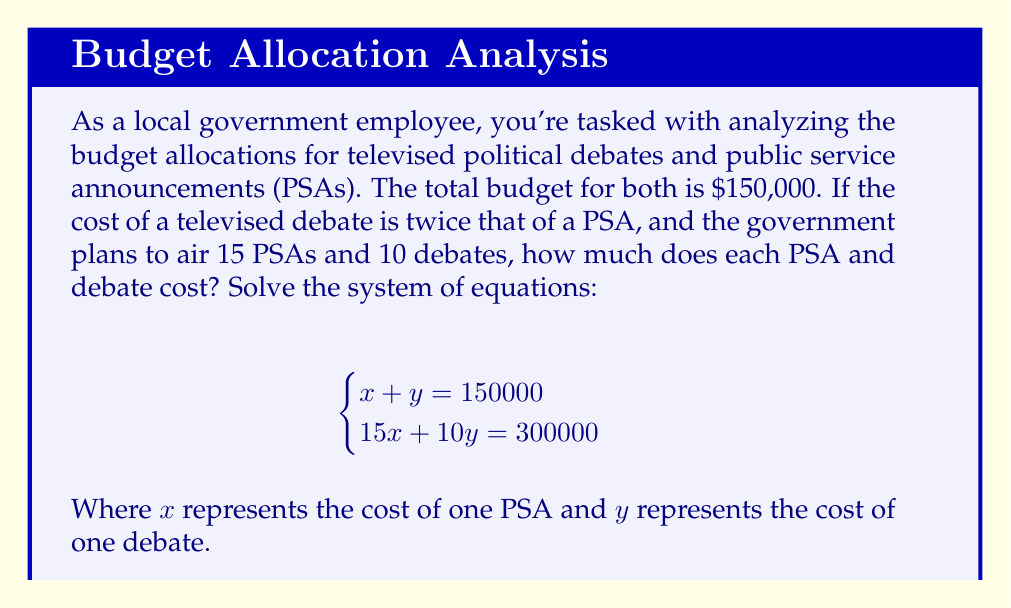Could you help me with this problem? Let's solve this system of equations step by step:

1) We have two equations:
   $$\begin{cases}
   x + y = 150000 \quad (1)\\
   15x + 10y = 300000 \quad (2)
   \end{cases}$$

2) Multiply equation (1) by 15:
   $$15x + 15y = 2250000 \quad (3)$$

3) Subtract equation (2) from equation (3):
   $$15x + 15y = 2250000$$
   $$-(15x + 10y = 300000)$$
   $$5y = 1950000$$

4) Solve for $y$:
   $$y = 1950000 \div 5 = 390000$$

5) Substitute this value of $y$ into equation (1):
   $$x + 390000 = 150000$$
   $$x = 150000 - 390000 = -240000$$

6) However, $x$ cannot be negative as it represents a cost. This means our initial assumption that $y$ represents the cost of one debate is incorrect.

7) Let's redefine our variables:
   $x$ = cost of one debate
   $y$ = cost of one PSA

8) Now our system becomes:
   $$\begin{cases}
   10x + 15y = 150000 \\
   x = 2y
   \end{cases}$$

9) Substitute $x = 2y$ into the first equation:
   $$10(2y) + 15y = 150000$$
   $$20y + 15y = 150000$$
   $$35y = 150000$$

10) Solve for $y$:
    $$y = 150000 \div 35 = 4285.71$$

11) Calculate $x$:
    $$x = 2y = 2(4285.71) = 8571.42$$

Therefore, each PSA costs $4,285.71 and each debate costs $8,571.42.
Answer: PSA: $4,285.71, Debate: $8,571.42 